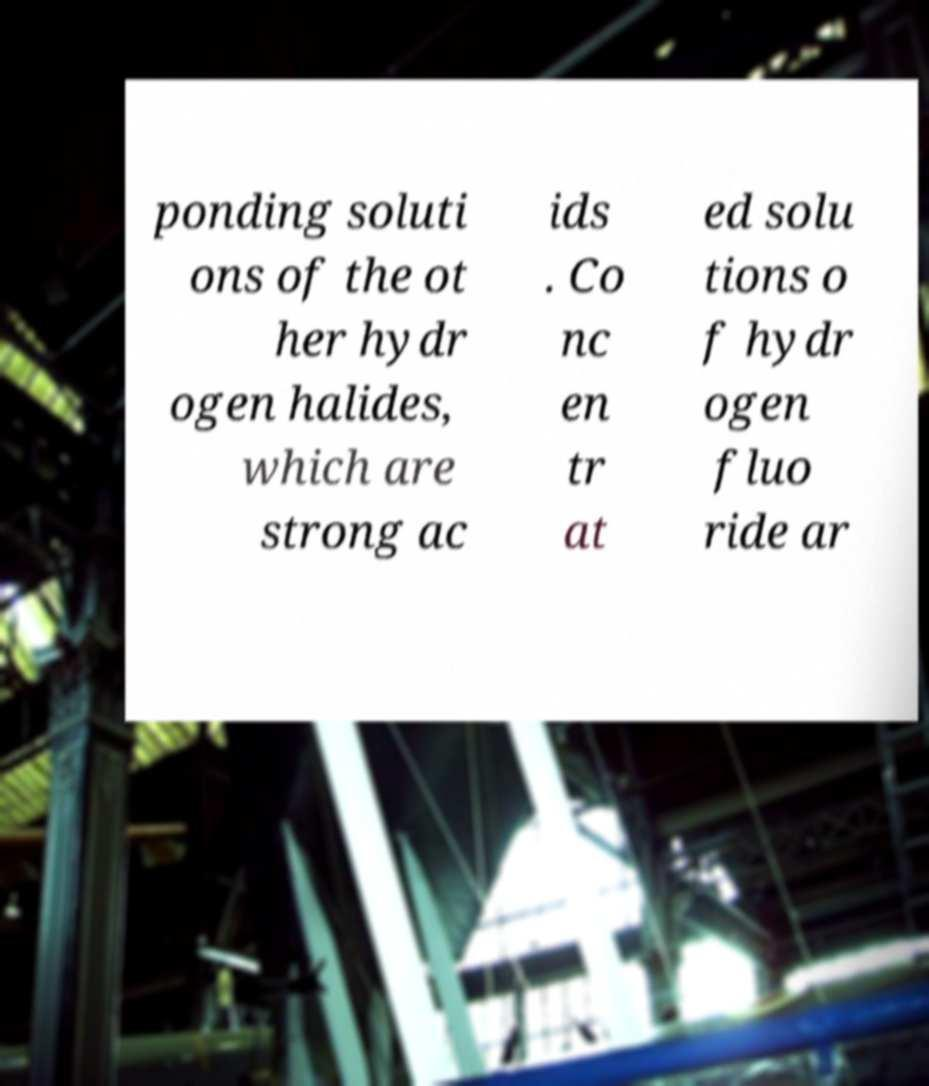Could you assist in decoding the text presented in this image and type it out clearly? ponding soluti ons of the ot her hydr ogen halides, which are strong ac ids . Co nc en tr at ed solu tions o f hydr ogen fluo ride ar 